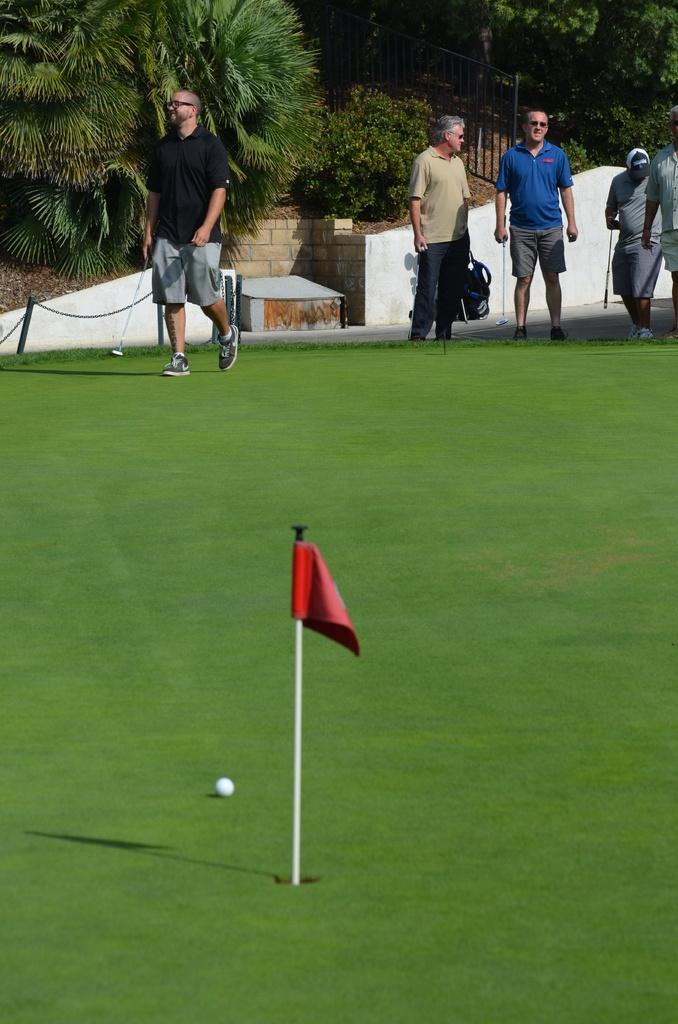What is on the pole that is visible in the image? There is a flag on a pole in the image. How is the pole positioned in the image? The pole is in a hole in the image. What object is on the grass in the image? There is a ball on the grass in the image. What can be seen in the distance in the image? There are people and trees visible in the background of the image. How many jellyfish are swimming in the background of the image? A: There are no jellyfish present in the image; it features a flag on a pole, a ball on the grass, and people and trees in the background. What date is marked on the calendar in the image? There is no calendar present in the image. 